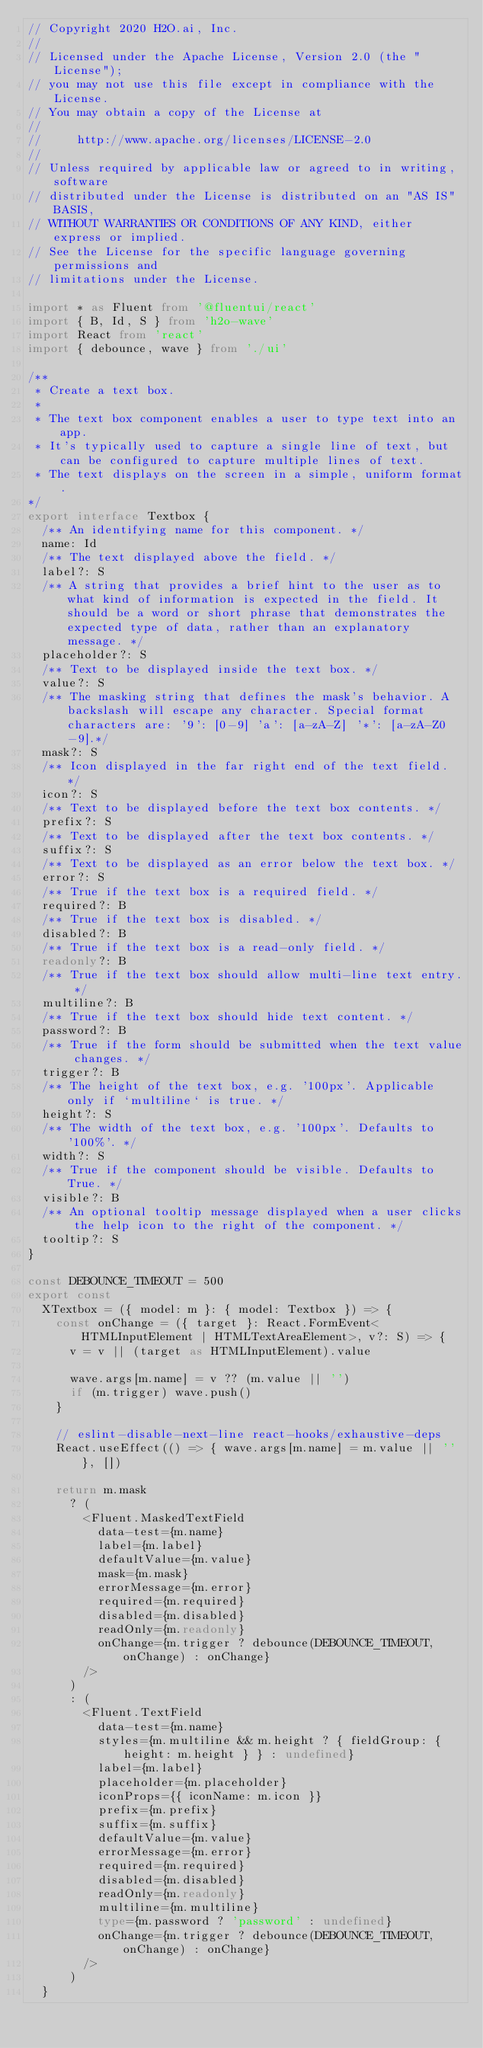<code> <loc_0><loc_0><loc_500><loc_500><_TypeScript_>// Copyright 2020 H2O.ai, Inc.
//
// Licensed under the Apache License, Version 2.0 (the "License");
// you may not use this file except in compliance with the License.
// You may obtain a copy of the License at
//
//     http://www.apache.org/licenses/LICENSE-2.0
//
// Unless required by applicable law or agreed to in writing, software
// distributed under the License is distributed on an "AS IS" BASIS,
// WITHOUT WARRANTIES OR CONDITIONS OF ANY KIND, either express or implied.
// See the License for the specific language governing permissions and
// limitations under the License.

import * as Fluent from '@fluentui/react'
import { B, Id, S } from 'h2o-wave'
import React from 'react'
import { debounce, wave } from './ui'

/**
 * Create a text box.
 *
 * The text box component enables a user to type text into an app.
 * It's typically used to capture a single line of text, but can be configured to capture multiple lines of text.
 * The text displays on the screen in a simple, uniform format.
*/
export interface Textbox {
  /** An identifying name for this component. */
  name: Id
  /** The text displayed above the field. */
  label?: S
  /** A string that provides a brief hint to the user as to what kind of information is expected in the field. It should be a word or short phrase that demonstrates the expected type of data, rather than an explanatory message. */
  placeholder?: S
  /** Text to be displayed inside the text box. */
  value?: S
  /** The masking string that defines the mask's behavior. A backslash will escape any character. Special format characters are: '9': [0-9] 'a': [a-zA-Z] '*': [a-zA-Z0-9].*/
  mask?: S
  /** Icon displayed in the far right end of the text field. */
  icon?: S
  /** Text to be displayed before the text box contents. */
  prefix?: S
  /** Text to be displayed after the text box contents. */
  suffix?: S
  /** Text to be displayed as an error below the text box. */
  error?: S
  /** True if the text box is a required field. */
  required?: B
  /** True if the text box is disabled. */
  disabled?: B
  /** True if the text box is a read-only field. */
  readonly?: B
  /** True if the text box should allow multi-line text entry. */
  multiline?: B
  /** True if the text box should hide text content. */
  password?: B
  /** True if the form should be submitted when the text value changes. */
  trigger?: B
  /** The height of the text box, e.g. '100px'. Applicable only if `multiline` is true. */
  height?: S
  /** The width of the text box, e.g. '100px'. Defaults to '100%'. */
  width?: S
  /** True if the component should be visible. Defaults to True. */
  visible?: B
  /** An optional tooltip message displayed when a user clicks the help icon to the right of the component. */
  tooltip?: S
}

const DEBOUNCE_TIMEOUT = 500
export const
  XTextbox = ({ model: m }: { model: Textbox }) => {
    const onChange = ({ target }: React.FormEvent<HTMLInputElement | HTMLTextAreaElement>, v?: S) => {
      v = v || (target as HTMLInputElement).value

      wave.args[m.name] = v ?? (m.value || '')
      if (m.trigger) wave.push()
    }

    // eslint-disable-next-line react-hooks/exhaustive-deps
    React.useEffect(() => { wave.args[m.name] = m.value || '' }, [])

    return m.mask
      ? (
        <Fluent.MaskedTextField
          data-test={m.name}
          label={m.label}
          defaultValue={m.value}
          mask={m.mask}
          errorMessage={m.error}
          required={m.required}
          disabled={m.disabled}
          readOnly={m.readonly}
          onChange={m.trigger ? debounce(DEBOUNCE_TIMEOUT, onChange) : onChange}
        />
      )
      : (
        <Fluent.TextField
          data-test={m.name}
          styles={m.multiline && m.height ? { fieldGroup: { height: m.height } } : undefined}
          label={m.label}
          placeholder={m.placeholder}
          iconProps={{ iconName: m.icon }}
          prefix={m.prefix}
          suffix={m.suffix}
          defaultValue={m.value}
          errorMessage={m.error}
          required={m.required}
          disabled={m.disabled}
          readOnly={m.readonly}
          multiline={m.multiline}
          type={m.password ? 'password' : undefined}
          onChange={m.trigger ? debounce(DEBOUNCE_TIMEOUT, onChange) : onChange}
        />
      )
  }</code> 